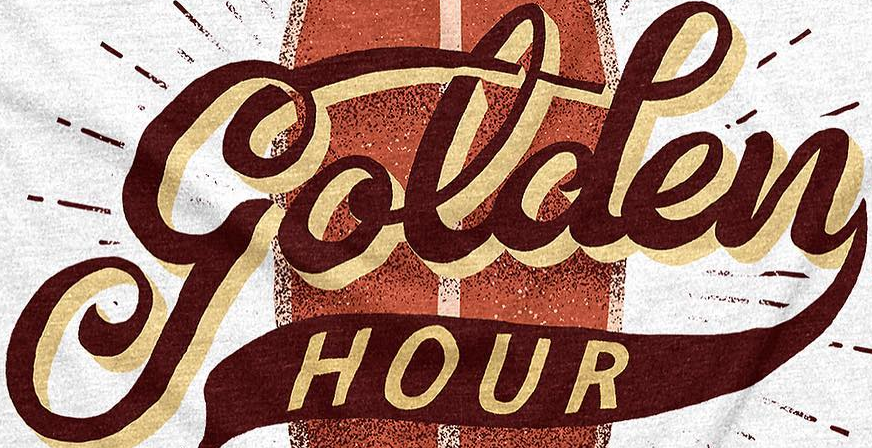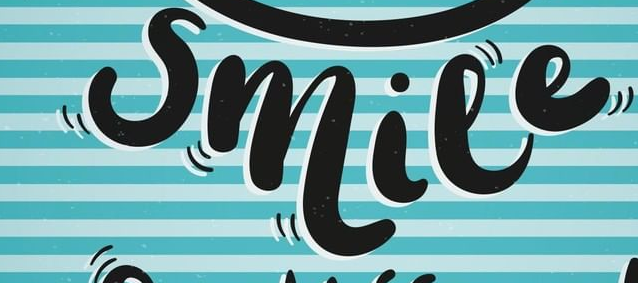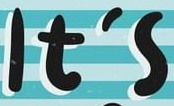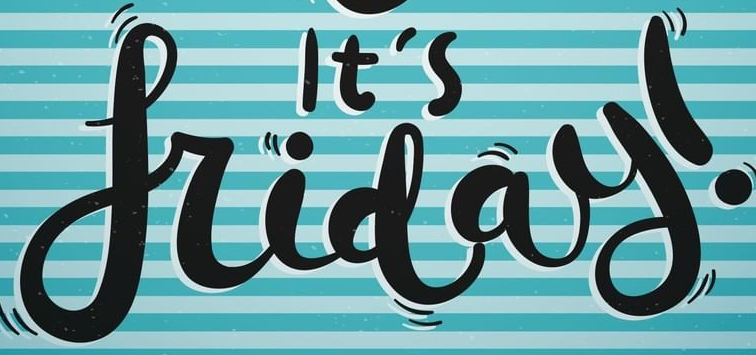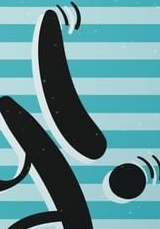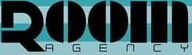Identify the words shown in these images in order, separated by a semicolon. golden; smile; It's; friday; !; ROOM 